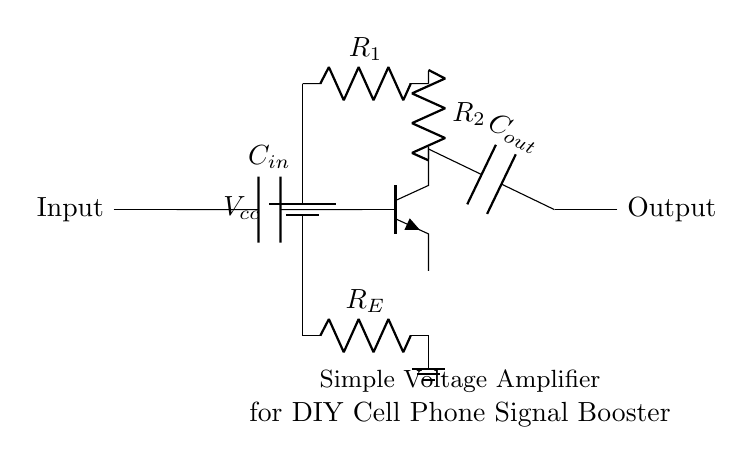What type of transistor is used in this circuit? The circuit uses an NPN transistor, which is indicated by the label 'npn' in the schematic. NPN transistors are essential for amplification applications.
Answer: NPN What is the purpose of capacitor C_in in the circuit? Capacitor C_in serves as an input coupling capacitor, allowing AC signals to pass while blocking DC components. This facilitates better amplification of the desired AC signal.
Answer: Input coupling What is the value of resistance R_E in this circuit? The value of resistance R_E is not specified in the circuit schematic. However, it plays an important role in stabilizing the transistor's operating point through emitter degeneration.
Answer: Not specified How many resistors are present in this amplifier circuit? There are three resistors shown in the circuit: R1, R2, and R_E. Each resistor contributes to the circuit's voltage division and biasing of the transistor.
Answer: Three What is the output capacitor used for in this circuit? The output capacitor C_out is used for coupling the amplified signal to the output load while blocking any DC component, ensuring that only the AC signal is transmitted to the output.
Answer: Output coupling What role does resistor R1 play in this circuit? Resistor R1 is part of the biasing network for the transistor, helping to set the base current necessary for the desired operation of the amplifier. This is crucial for determining the transistor's operational state.
Answer: Biasing network What does the output represent in this voltage amplifier circuit? The output represents the amplified version of the input signal. It is taken across the output capacitor C_out, which isolates the AC signal from any DC levels in the circuit.
Answer: Amplified signal 